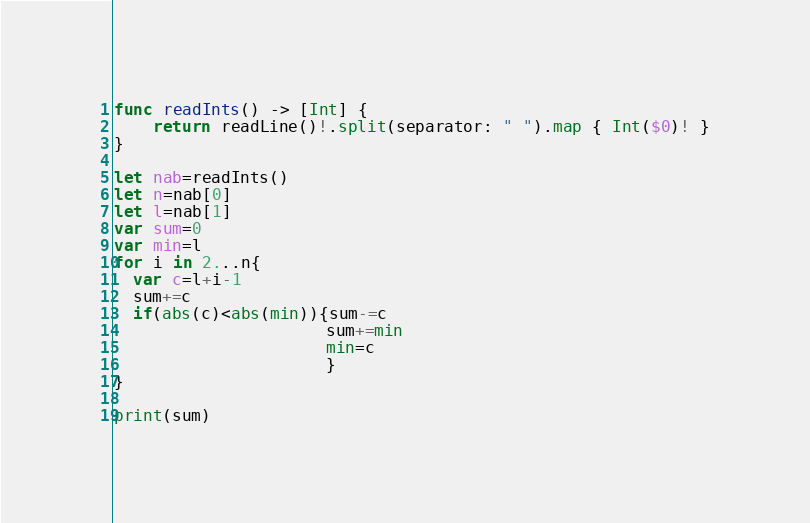Convert code to text. <code><loc_0><loc_0><loc_500><loc_500><_Swift_>func readInts() -> [Int] {
    return readLine()!.split(separator: " ").map { Int($0)! }
}

let nab=readInts()
let n=nab[0]
let l=nab[1]
var sum=0
var min=l
for i in 2...n{
  var c=l+i-1
  sum+=c
  if(abs(c)<abs(min)){sum-=c
                      sum+=min
                      min=c
                      }
}

print(sum)</code> 